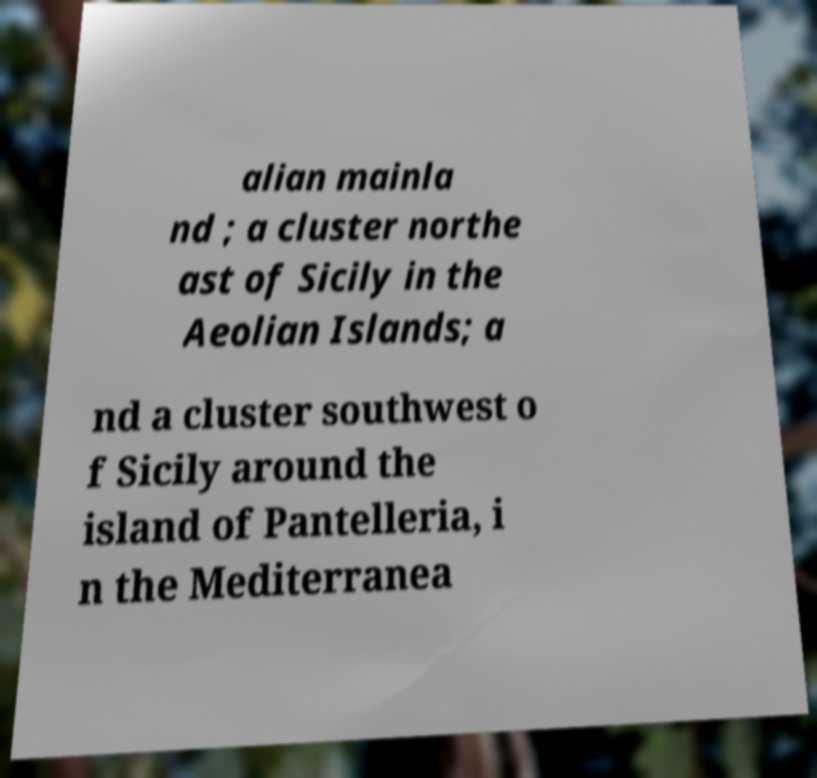Please identify and transcribe the text found in this image. alian mainla nd ; a cluster northe ast of Sicily in the Aeolian Islands; a nd a cluster southwest o f Sicily around the island of Pantelleria, i n the Mediterranea 